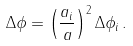Convert formula to latex. <formula><loc_0><loc_0><loc_500><loc_500>\Delta \phi = \left ( \frac { a _ { i } } { a } \right ) ^ { 2 } \Delta \phi _ { i } \, .</formula> 